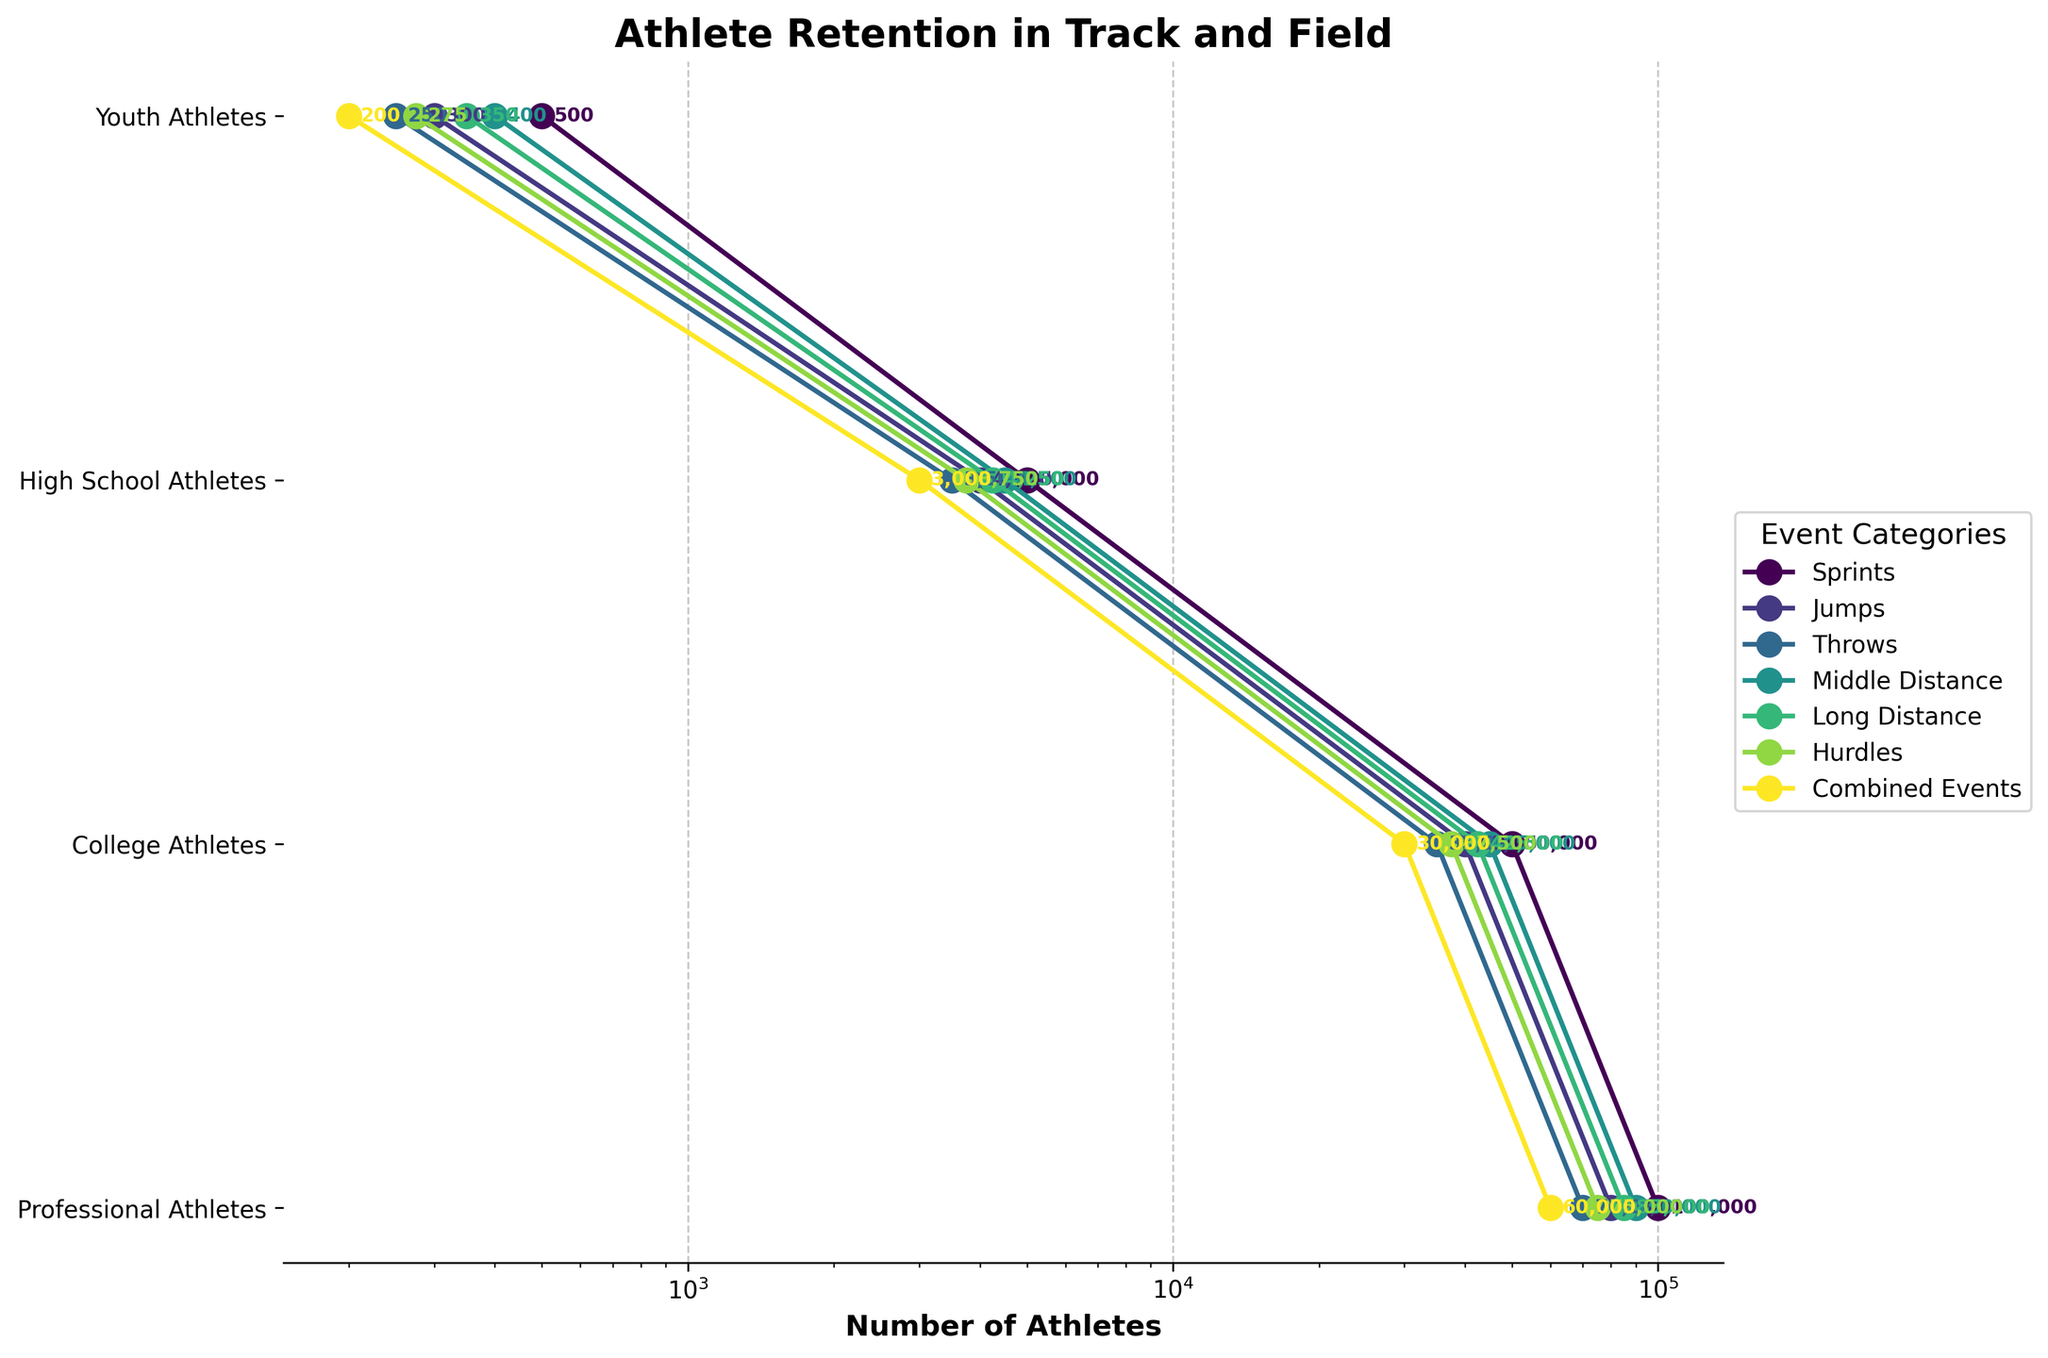What is the title of the figure? The title of the figure is prominently displayed at the top of the plot. It helps to identify the main topic or purpose of the visualization. In this case, it's clearly stated at the top.
Answer: Athlete Retention in Track and Field What levels of athletic progression are shown on the y-axis? The y-axis of the plot labels the progression levels of athletes, starting from the base level to the top. The labels are reversed to show them ascending as you move down.
Answer: Professional Athletes, College Athletes, High School Athletes, Youth Athletes Which event category retains the most athletes at the professional level? By examining the rightmost data points on the plot for each event category, we can identify the event with the highest number of athletes at the Professional Athletes level.
Answer: Sprints What is the difference in the number of High School Athletes between the Throws and Combined Events categories? To find the difference, locate the number of High School Athletes for both Throws and Combined Events on the plot, and subtract the latter from the former. Throws: 35,000, Combined Events: 30,000. So, the difference is 35,000 - 30,000.
Answer: 5,000 What is the average number of College Athletes across all event categories? To find the average, sum the number of College Athletes for all categories and then divide by the total number of categories. The values are: 5000, 4000, 3500, 4500, 4250, 3750, 3000. Sum these values and divide by 7.
Answer: 4000 Which two event categories have the closest retention rates at the College Athlete level? To identify this, compare the College Athlete numbers for all event categories and find the two that have the smallest difference. The closest values are Jumps and Throws at 4000 and 3500, respectively. The difference is 500.
Answer: Jumps and Throws What is the retention drop from Youth Athletes to Professional Athletes in the Hurdles category? Find the number of Youth Athletes and Professional Athletes in the Hurdles category, and subtract the latter from the former to get the drop. Youth: 75,000, Professional: 275. 75,000 - 275.
Answer: 74,725 Which event category has the highest retention rate from High School Athletes to College Athletes? Calculate the retention rate by finding the ratio (or percent) for each event category and determine which one is the highest. This is (College Athletes / High School Athletes) * 100. Sprints have 5000 / 50000 = 0.1 or 10%. It needs to be manually calculated for all categories to identify the highest.
Answer: Middle Distance What pattern can be observed in the retention rates for the Jumps category across all levels? Look at the plotted points from Youth to Professional levels for the Jumps category and describe the retention trend observed. The number of athletes consistently decreases at each subsequent level
Answer: Consistent Decrease 